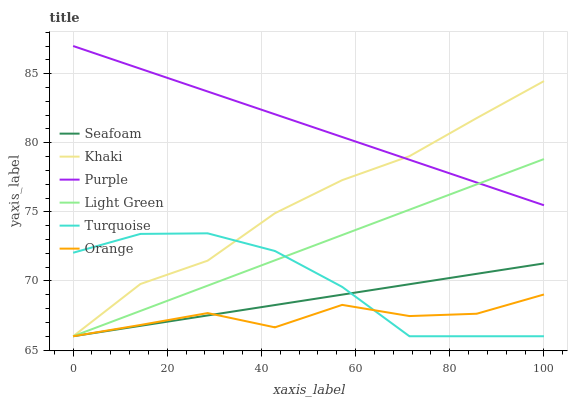Does Khaki have the minimum area under the curve?
Answer yes or no. No. Does Khaki have the maximum area under the curve?
Answer yes or no. No. Is Khaki the smoothest?
Answer yes or no. No. Is Khaki the roughest?
Answer yes or no. No. Does Purple have the lowest value?
Answer yes or no. No. Does Khaki have the highest value?
Answer yes or no. No. Is Orange less than Purple?
Answer yes or no. Yes. Is Purple greater than Turquoise?
Answer yes or no. Yes. Does Orange intersect Purple?
Answer yes or no. No. 